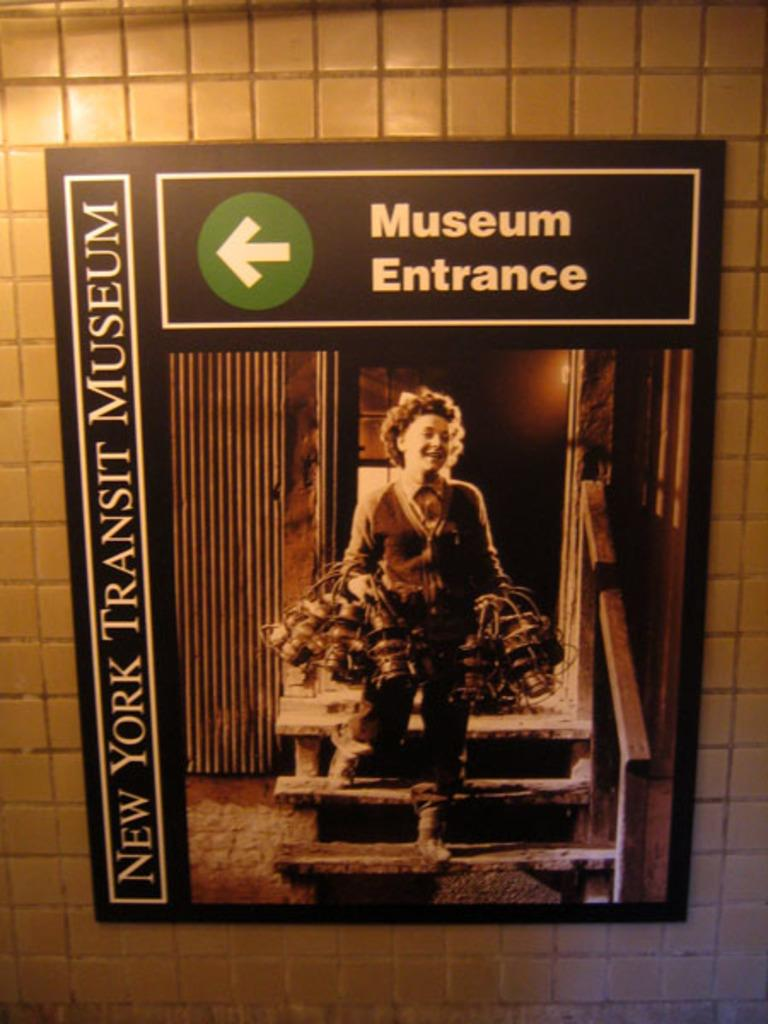Provide a one-sentence caption for the provided image. A sign on a white tile wall indicating the direction of the entrance to the New York Transit Museum. 